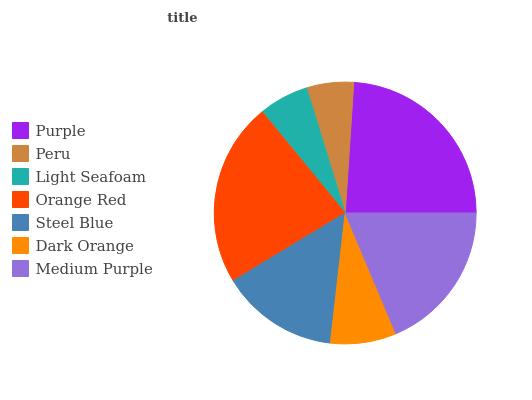Is Peru the minimum?
Answer yes or no. Yes. Is Purple the maximum?
Answer yes or no. Yes. Is Light Seafoam the minimum?
Answer yes or no. No. Is Light Seafoam the maximum?
Answer yes or no. No. Is Light Seafoam greater than Peru?
Answer yes or no. Yes. Is Peru less than Light Seafoam?
Answer yes or no. Yes. Is Peru greater than Light Seafoam?
Answer yes or no. No. Is Light Seafoam less than Peru?
Answer yes or no. No. Is Steel Blue the high median?
Answer yes or no. Yes. Is Steel Blue the low median?
Answer yes or no. Yes. Is Medium Purple the high median?
Answer yes or no. No. Is Medium Purple the low median?
Answer yes or no. No. 